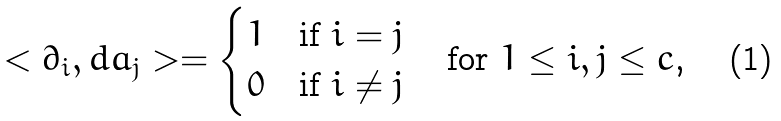Convert formula to latex. <formula><loc_0><loc_0><loc_500><loc_500>< \partial _ { i } , d a _ { j } > = \begin{cases} 1 & \text {if $i=j$} \\ 0 & \text {if $i\neq j$} \end{cases} \quad \text {for $1\leq i,j\leq c$,}</formula> 